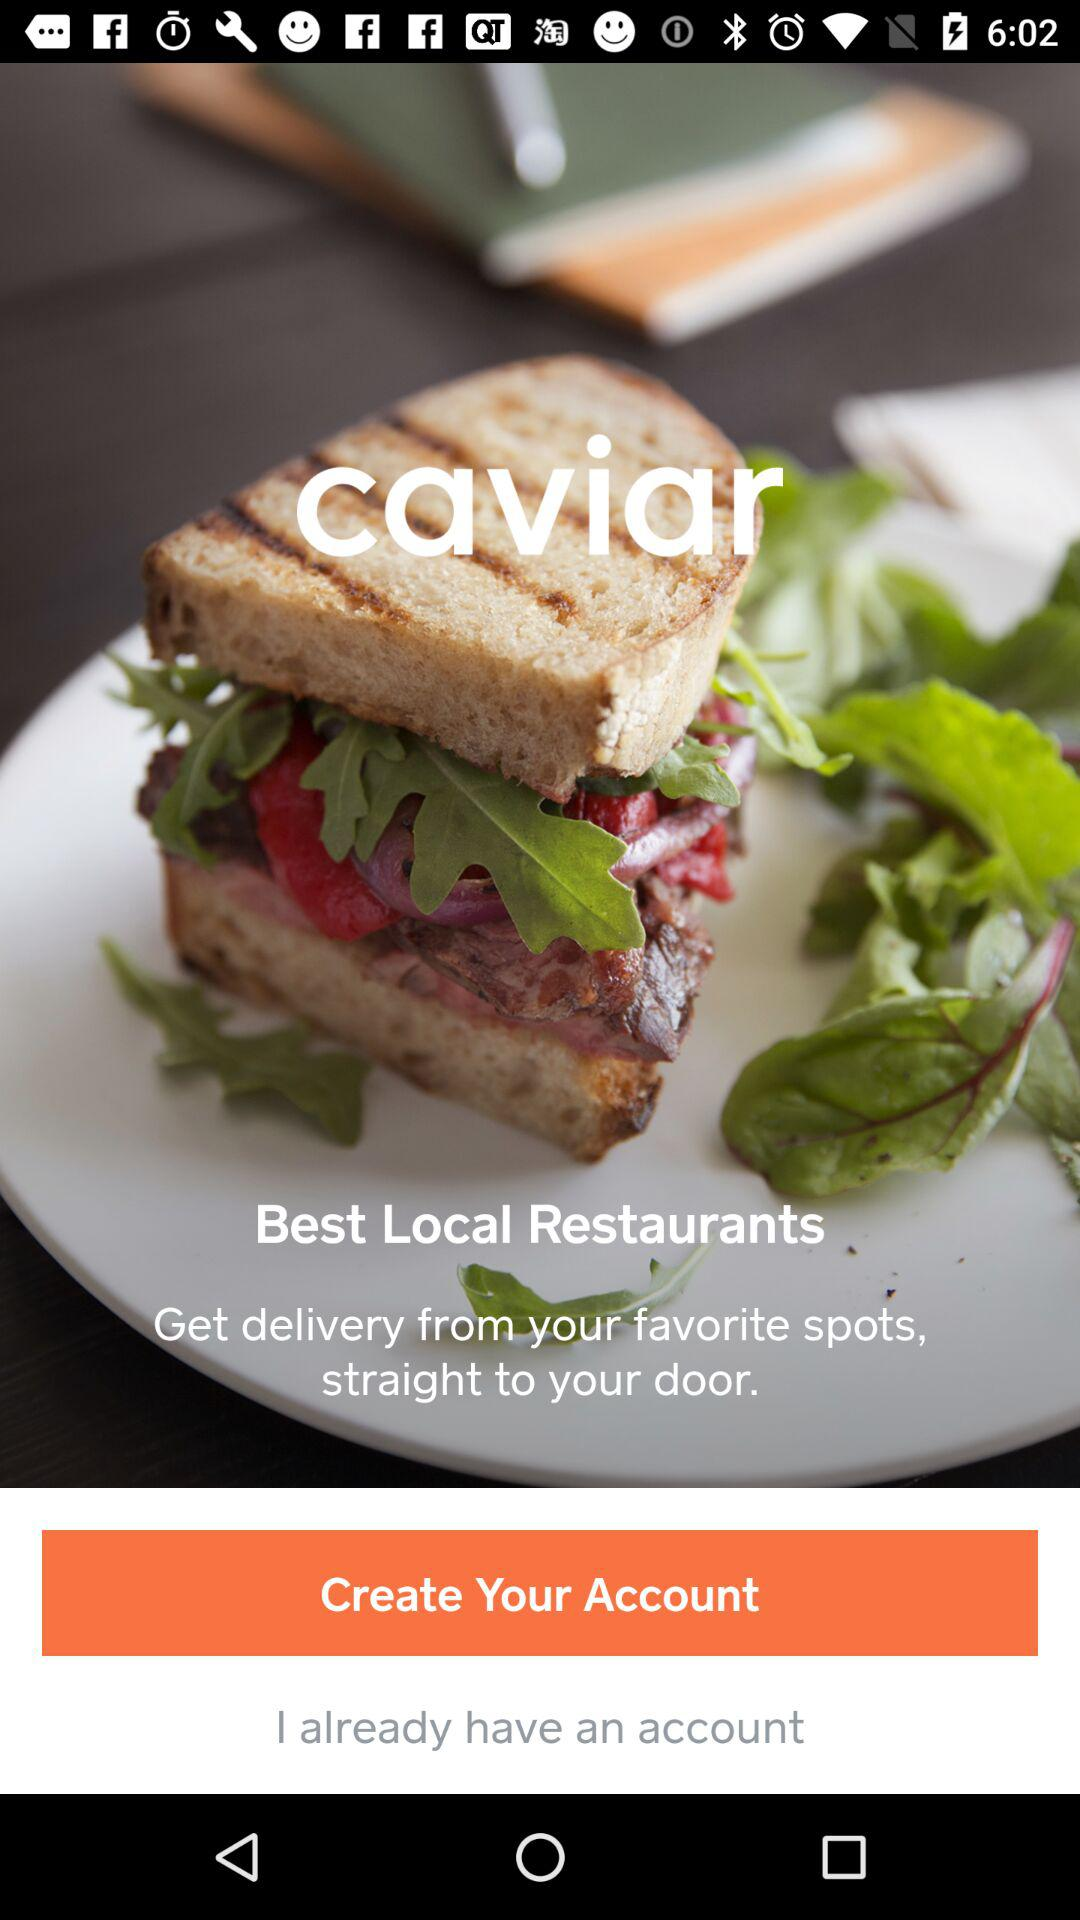Where are the user's favorite spots?
When the provided information is insufficient, respond with <no answer>. <no answer> 